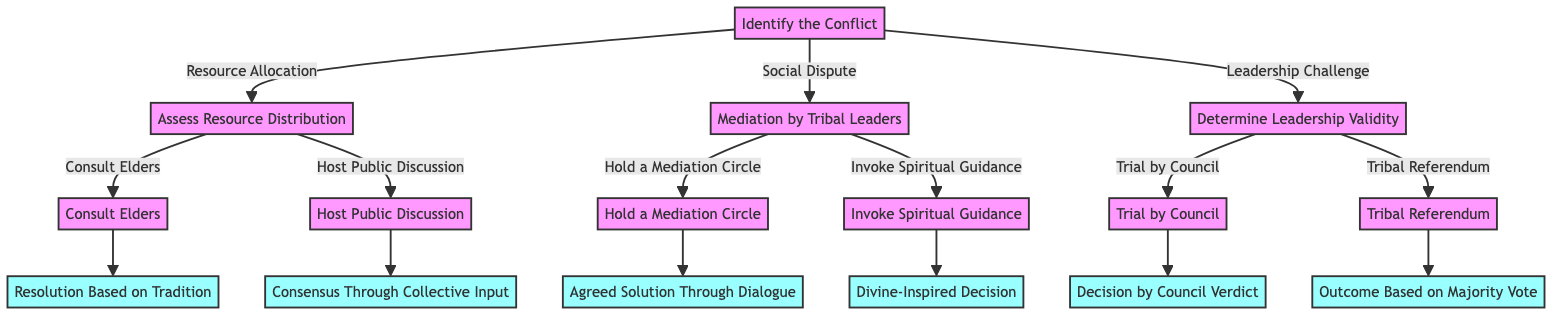What are the three types of conflicts identified in the diagram? The diagram identifies three types of conflicts: Resource Allocation, Social Dispute, and Leadership Challenge. Each conflict is represented as an option stemming from the first step, "Identify the Conflict."
Answer: Resource Allocation, Social Dispute, Leadership Challenge What is the second step after identifying a resource-related conflict? After identifying a resource-related conflict, the next step is "Assess Resource Distribution," which is specifically linked to the "Resource Allocation" option.
Answer: Assess Resource Distribution What outcome results from consulting elders in resource conflicts? The outcome of consulting elders is "Resolution Based on Tradition," which is the result node linked to that specific step in the decision-making process.
Answer: Resolution Based on Tradition How do social disputes get mediated according to the diagram? Social disputes are mediated by "Mediation by Tribal Leaders," which provides two options: "Hold a Mediation Circle" and "Invoke Spiritual Guidance" for resolution.
Answer: Mediation by Tribal Leaders What is the first action taken for leadership challenges? The initial action taken in leadership challenges is to "Determine Leadership Validity," leading to two possible paths: "Trial by Council" or "Tribal Referendum."
Answer: Determine Leadership Validity How many outcomes arise from the decision tree in total? The decision tree results in a total of six distinct outcomes, each tied to resolution steps that follow the decision-making processes for the various conflicts.
Answer: Six outcomes What is the relationship between "Trial by Council" and its result? "Trial by Council" is connected to the result "Decision by Council Verdict," indicating that the outcome of this step is determined by a formal decision made by the council.
Answer: Decision by Council Verdict What method leads to consensus in resource distribution disputes? "Host Public Discussion" leads to consensus, resulting in the decision "Consensus Through Collective Input," which reflects the input of tribe members in resolving the issue.
Answer: Consensus Through Collective Input What step does one take after hosting a mediation circle? After hosting a mediation circle, the next step leads to the result "Agreed Solution Through Dialogue," which is the outcome of that specific step in resolving social disputes.
Answer: Agreed Solution Through Dialogue 